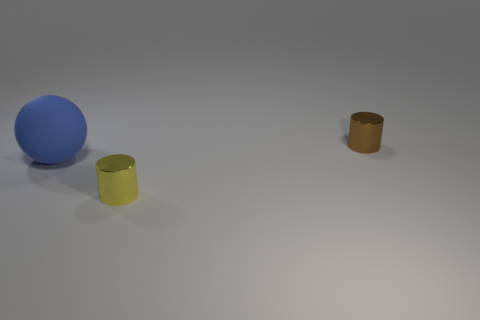Add 3 large green metallic blocks. How many objects exist? 6 Subtract all cylinders. How many objects are left? 1 Subtract all large blue things. Subtract all small red blocks. How many objects are left? 2 Add 2 tiny yellow cylinders. How many tiny yellow cylinders are left? 3 Add 3 cyan cylinders. How many cyan cylinders exist? 3 Subtract 0 red blocks. How many objects are left? 3 